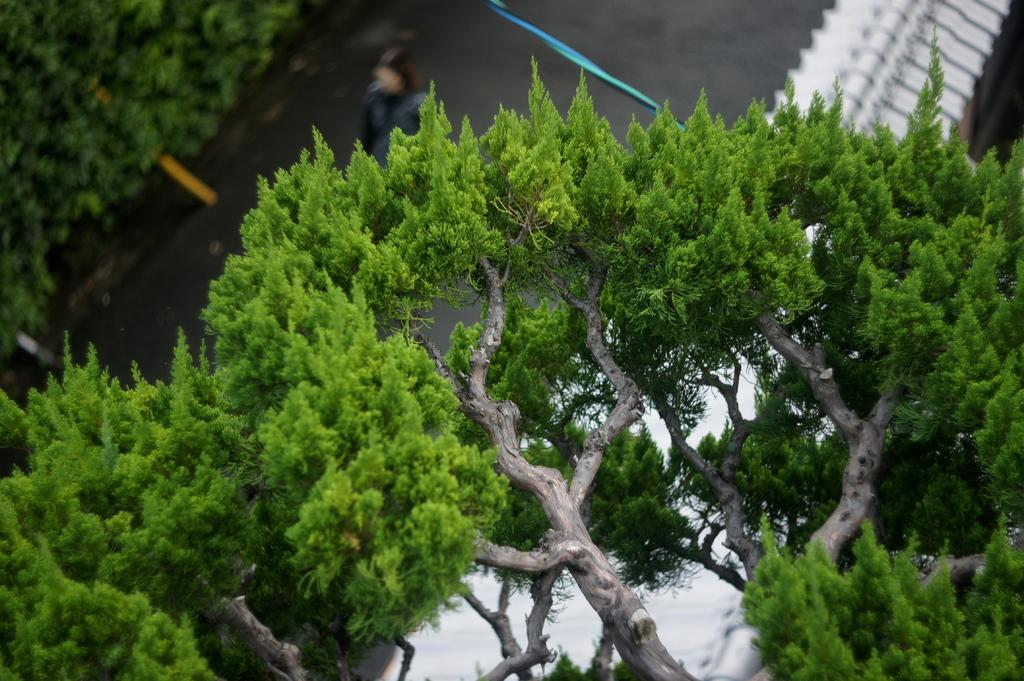What is located in the foreground of the image? There is a tree in the foreground of the image. What role does the tree seem to play in the image? The tree appears to be a boundary. What is the person in the image doing? A person is walking on the road in the image. Can you describe the natural elements visible in the image? There are trees visible in the image. What type of sponge is being used by the committee in the image? There is no committee or sponge present in the image. Can you tell me the name of the person's brother in the image? There is no brother present in the image. 